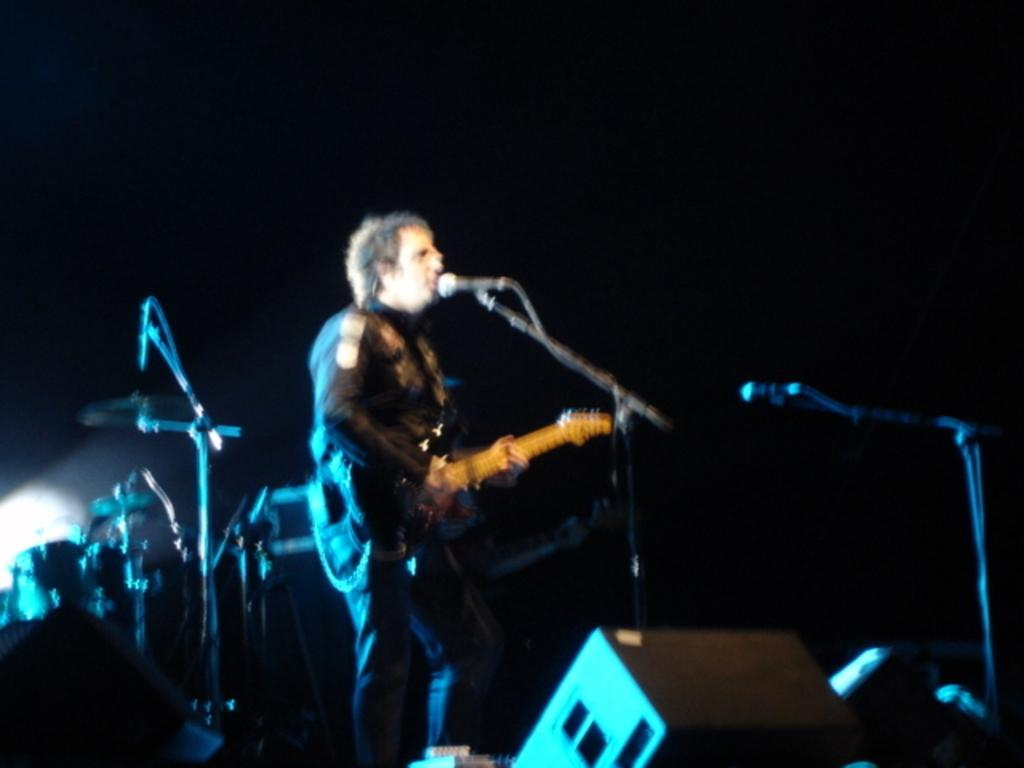What is the man in the image holding? The man is holding a guitar. What is the man standing in front of? The man is standing in front of a mic. Can you describe the background of the image? There is a musical instrument in the background of the image. Where is the basin and faucet located in the image? There is no basin or faucet present in the image. What type of stocking is the man wearing in the image? The man is not wearing any stockings in the image. 